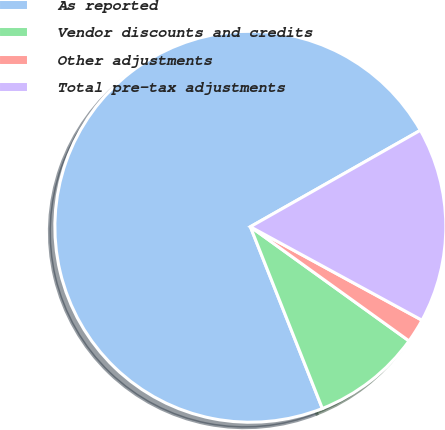Convert chart. <chart><loc_0><loc_0><loc_500><loc_500><pie_chart><fcel>As reported<fcel>Vendor discounts and credits<fcel>Other adjustments<fcel>Total pre-tax adjustments<nl><fcel>72.79%<fcel>9.07%<fcel>1.99%<fcel>16.15%<nl></chart> 